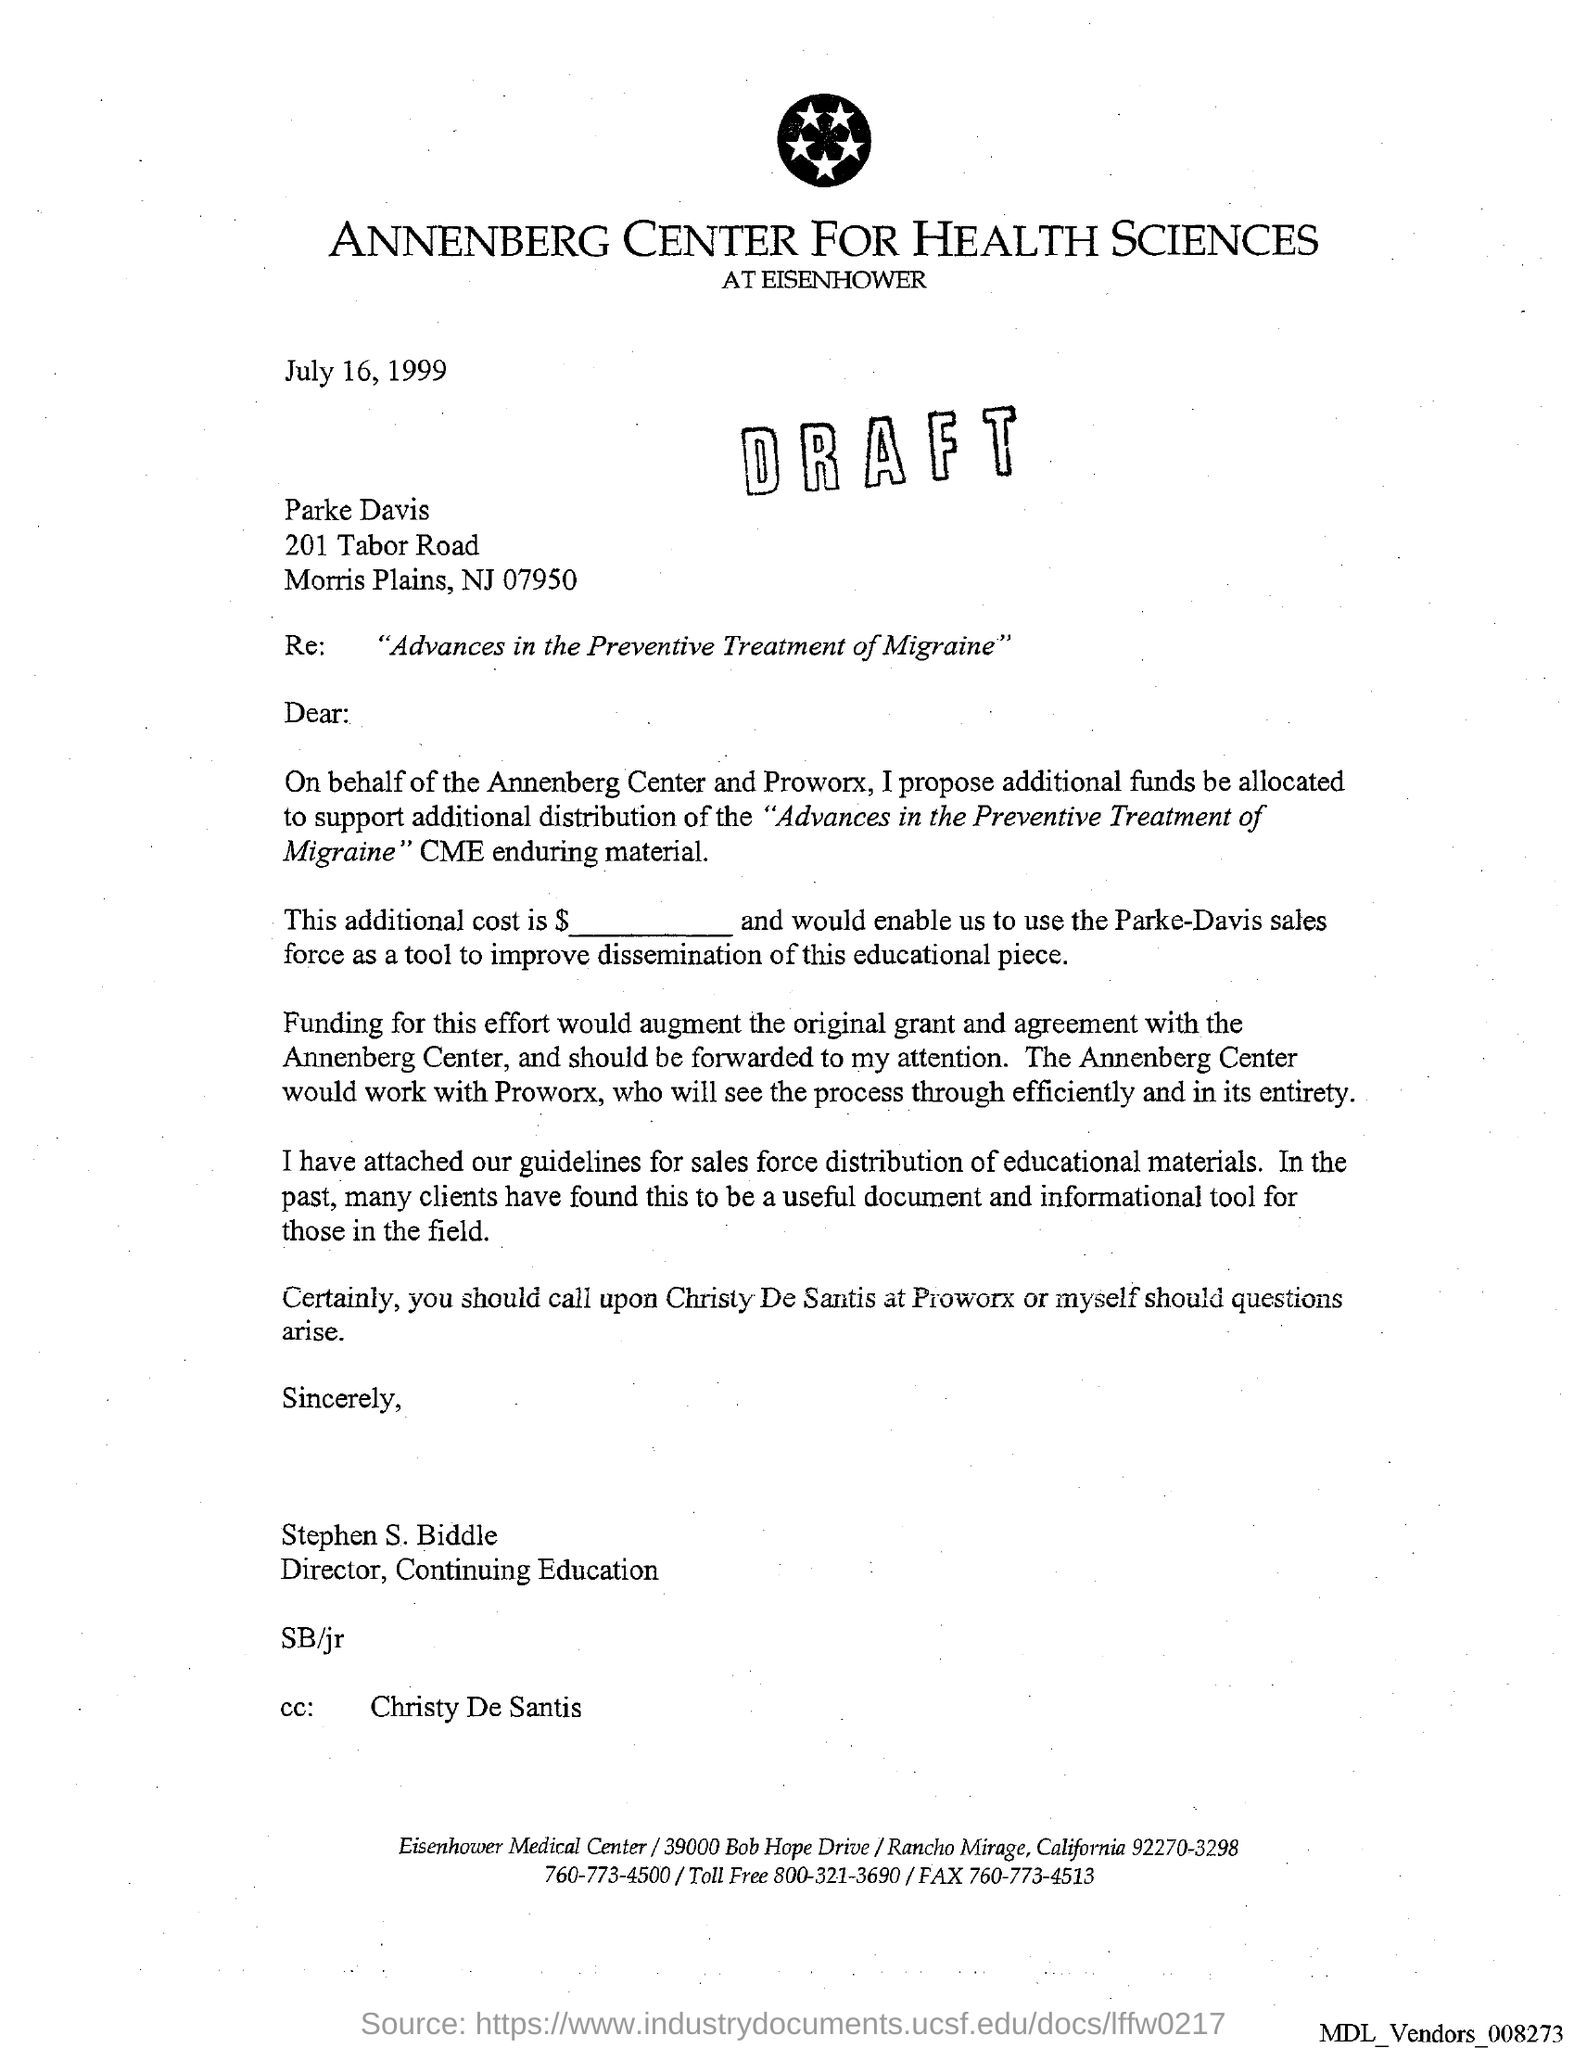Which company is mentioned in the letter head?
Provide a short and direct response. ANNENBERG CENTER FOR HEALTH SCIENCES. What is the issued date of this letter?
Give a very brief answer. July 16, 1999. Who is the sender of this letter?
Give a very brief answer. Stephen S. Biddle. Who is marked in the cc of this letter?
Keep it short and to the point. Christy De Santis. 